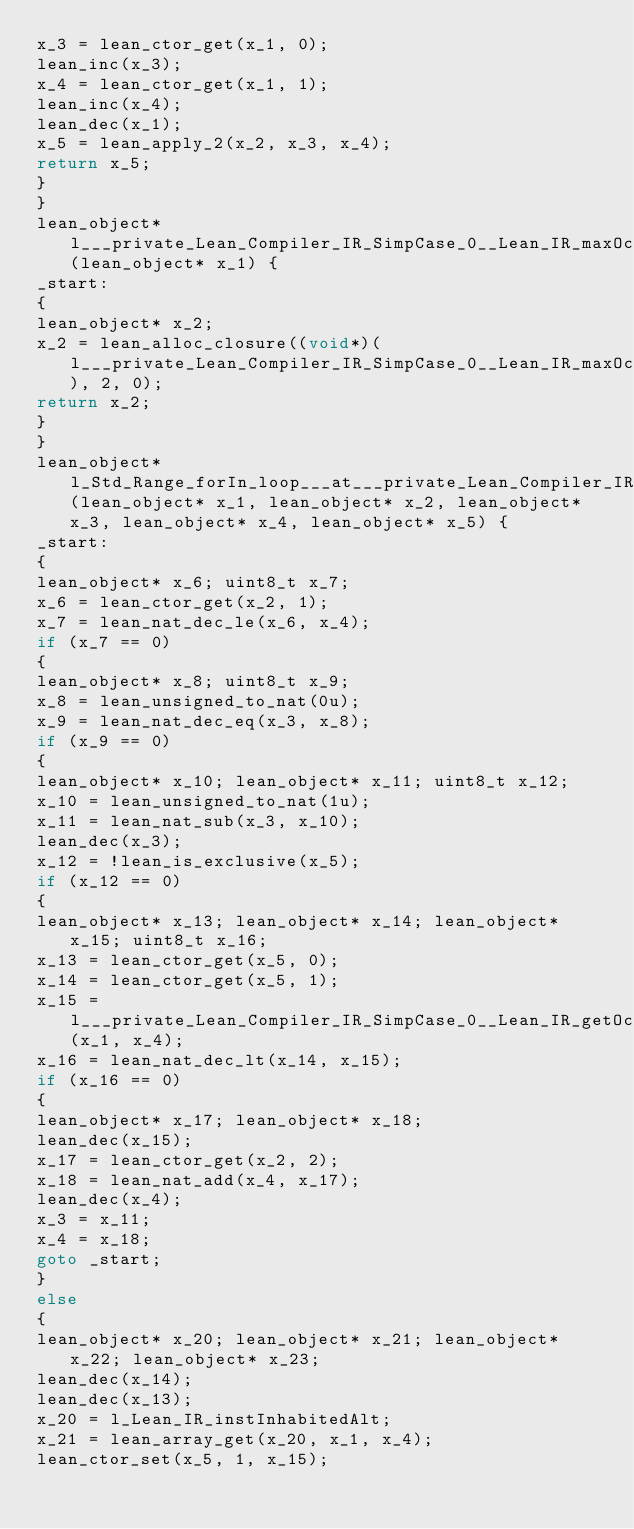Convert code to text. <code><loc_0><loc_0><loc_500><loc_500><_C_>x_3 = lean_ctor_get(x_1, 0);
lean_inc(x_3);
x_4 = lean_ctor_get(x_1, 1);
lean_inc(x_4);
lean_dec(x_1);
x_5 = lean_apply_2(x_2, x_3, x_4);
return x_5;
}
}
lean_object* l___private_Lean_Compiler_IR_SimpCase_0__Lean_IR_maxOccs_match__2(lean_object* x_1) {
_start:
{
lean_object* x_2; 
x_2 = lean_alloc_closure((void*)(l___private_Lean_Compiler_IR_SimpCase_0__Lean_IR_maxOccs_match__2___rarg), 2, 0);
return x_2;
}
}
lean_object* l_Std_Range_forIn_loop___at___private_Lean_Compiler_IR_SimpCase_0__Lean_IR_maxOccs___spec__1(lean_object* x_1, lean_object* x_2, lean_object* x_3, lean_object* x_4, lean_object* x_5) {
_start:
{
lean_object* x_6; uint8_t x_7; 
x_6 = lean_ctor_get(x_2, 1);
x_7 = lean_nat_dec_le(x_6, x_4);
if (x_7 == 0)
{
lean_object* x_8; uint8_t x_9; 
x_8 = lean_unsigned_to_nat(0u);
x_9 = lean_nat_dec_eq(x_3, x_8);
if (x_9 == 0)
{
lean_object* x_10; lean_object* x_11; uint8_t x_12; 
x_10 = lean_unsigned_to_nat(1u);
x_11 = lean_nat_sub(x_3, x_10);
lean_dec(x_3);
x_12 = !lean_is_exclusive(x_5);
if (x_12 == 0)
{
lean_object* x_13; lean_object* x_14; lean_object* x_15; uint8_t x_16; 
x_13 = lean_ctor_get(x_5, 0);
x_14 = lean_ctor_get(x_5, 1);
x_15 = l___private_Lean_Compiler_IR_SimpCase_0__Lean_IR_getOccsOf(x_1, x_4);
x_16 = lean_nat_dec_lt(x_14, x_15);
if (x_16 == 0)
{
lean_object* x_17; lean_object* x_18; 
lean_dec(x_15);
x_17 = lean_ctor_get(x_2, 2);
x_18 = lean_nat_add(x_4, x_17);
lean_dec(x_4);
x_3 = x_11;
x_4 = x_18;
goto _start;
}
else
{
lean_object* x_20; lean_object* x_21; lean_object* x_22; lean_object* x_23; 
lean_dec(x_14);
lean_dec(x_13);
x_20 = l_Lean_IR_instInhabitedAlt;
x_21 = lean_array_get(x_20, x_1, x_4);
lean_ctor_set(x_5, 1, x_15);</code> 